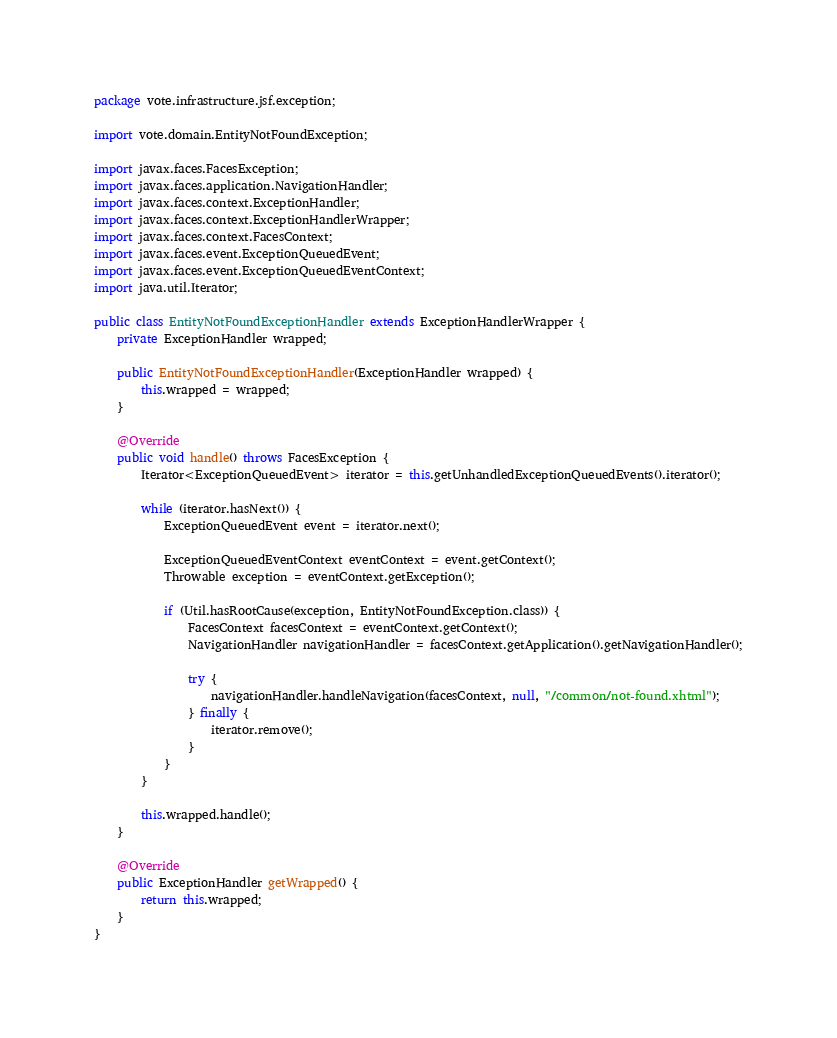Convert code to text. <code><loc_0><loc_0><loc_500><loc_500><_Java_>package vote.infrastructure.jsf.exception;

import vote.domain.EntityNotFoundException;

import javax.faces.FacesException;
import javax.faces.application.NavigationHandler;
import javax.faces.context.ExceptionHandler;
import javax.faces.context.ExceptionHandlerWrapper;
import javax.faces.context.FacesContext;
import javax.faces.event.ExceptionQueuedEvent;
import javax.faces.event.ExceptionQueuedEventContext;
import java.util.Iterator;

public class EntityNotFoundExceptionHandler extends ExceptionHandlerWrapper {
    private ExceptionHandler wrapped;

    public EntityNotFoundExceptionHandler(ExceptionHandler wrapped) {
        this.wrapped = wrapped;
    }

    @Override
    public void handle() throws FacesException {
        Iterator<ExceptionQueuedEvent> iterator = this.getUnhandledExceptionQueuedEvents().iterator();

        while (iterator.hasNext()) {
            ExceptionQueuedEvent event = iterator.next();

            ExceptionQueuedEventContext eventContext = event.getContext();
            Throwable exception = eventContext.getException();

            if (Util.hasRootCause(exception, EntityNotFoundException.class)) {
                FacesContext facesContext = eventContext.getContext();
                NavigationHandler navigationHandler = facesContext.getApplication().getNavigationHandler();

                try {
                    navigationHandler.handleNavigation(facesContext, null, "/common/not-found.xhtml");
                } finally {
                    iterator.remove();
                }
            }
        }

        this.wrapped.handle();
    }

    @Override
    public ExceptionHandler getWrapped() {
        return this.wrapped;
    }
}
</code> 